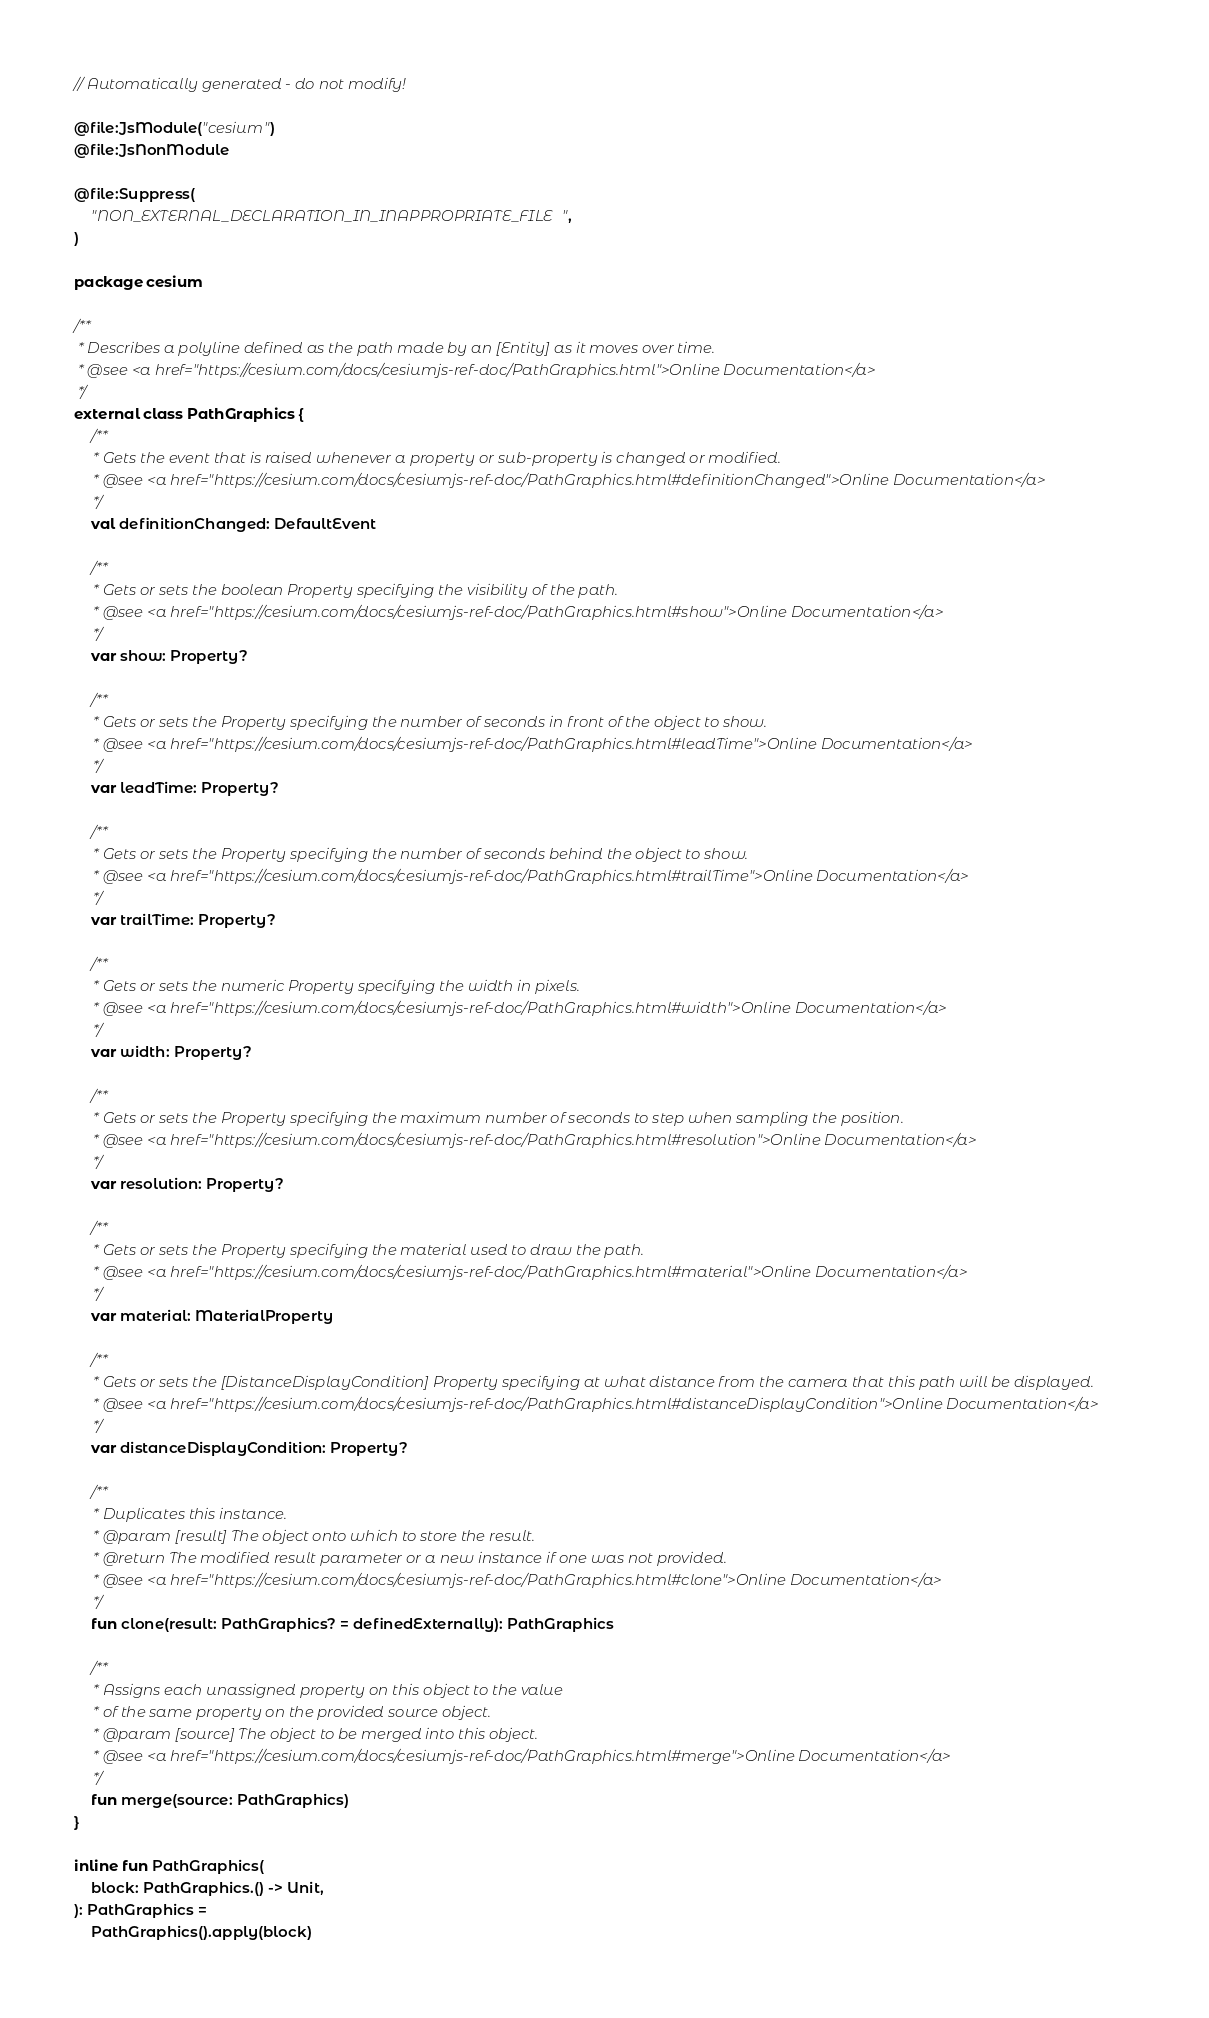<code> <loc_0><loc_0><loc_500><loc_500><_Kotlin_>// Automatically generated - do not modify!

@file:JsModule("cesium")
@file:JsNonModule

@file:Suppress(
    "NON_EXTERNAL_DECLARATION_IN_INAPPROPRIATE_FILE",
)

package cesium

/**
 * Describes a polyline defined as the path made by an [Entity] as it moves over time.
 * @see <a href="https://cesium.com/docs/cesiumjs-ref-doc/PathGraphics.html">Online Documentation</a>
 */
external class PathGraphics {
    /**
     * Gets the event that is raised whenever a property or sub-property is changed or modified.
     * @see <a href="https://cesium.com/docs/cesiumjs-ref-doc/PathGraphics.html#definitionChanged">Online Documentation</a>
     */
    val definitionChanged: DefaultEvent

    /**
     * Gets or sets the boolean Property specifying the visibility of the path.
     * @see <a href="https://cesium.com/docs/cesiumjs-ref-doc/PathGraphics.html#show">Online Documentation</a>
     */
    var show: Property?

    /**
     * Gets or sets the Property specifying the number of seconds in front of the object to show.
     * @see <a href="https://cesium.com/docs/cesiumjs-ref-doc/PathGraphics.html#leadTime">Online Documentation</a>
     */
    var leadTime: Property?

    /**
     * Gets or sets the Property specifying the number of seconds behind the object to show.
     * @see <a href="https://cesium.com/docs/cesiumjs-ref-doc/PathGraphics.html#trailTime">Online Documentation</a>
     */
    var trailTime: Property?

    /**
     * Gets or sets the numeric Property specifying the width in pixels.
     * @see <a href="https://cesium.com/docs/cesiumjs-ref-doc/PathGraphics.html#width">Online Documentation</a>
     */
    var width: Property?

    /**
     * Gets or sets the Property specifying the maximum number of seconds to step when sampling the position.
     * @see <a href="https://cesium.com/docs/cesiumjs-ref-doc/PathGraphics.html#resolution">Online Documentation</a>
     */
    var resolution: Property?

    /**
     * Gets or sets the Property specifying the material used to draw the path.
     * @see <a href="https://cesium.com/docs/cesiumjs-ref-doc/PathGraphics.html#material">Online Documentation</a>
     */
    var material: MaterialProperty

    /**
     * Gets or sets the [DistanceDisplayCondition] Property specifying at what distance from the camera that this path will be displayed.
     * @see <a href="https://cesium.com/docs/cesiumjs-ref-doc/PathGraphics.html#distanceDisplayCondition">Online Documentation</a>
     */
    var distanceDisplayCondition: Property?

    /**
     * Duplicates this instance.
     * @param [result] The object onto which to store the result.
     * @return The modified result parameter or a new instance if one was not provided.
     * @see <a href="https://cesium.com/docs/cesiumjs-ref-doc/PathGraphics.html#clone">Online Documentation</a>
     */
    fun clone(result: PathGraphics? = definedExternally): PathGraphics

    /**
     * Assigns each unassigned property on this object to the value
     * of the same property on the provided source object.
     * @param [source] The object to be merged into this object.
     * @see <a href="https://cesium.com/docs/cesiumjs-ref-doc/PathGraphics.html#merge">Online Documentation</a>
     */
    fun merge(source: PathGraphics)
}

inline fun PathGraphics(
    block: PathGraphics.() -> Unit,
): PathGraphics =
    PathGraphics().apply(block)
</code> 